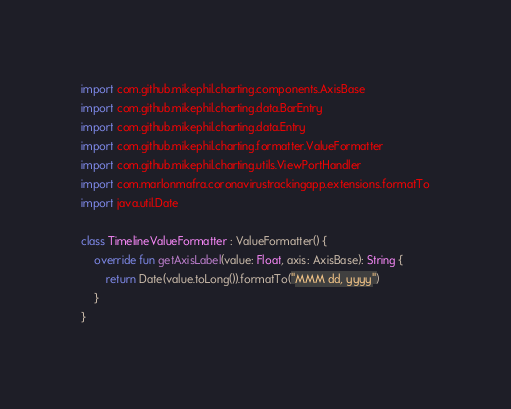<code> <loc_0><loc_0><loc_500><loc_500><_Kotlin_>import com.github.mikephil.charting.components.AxisBase
import com.github.mikephil.charting.data.BarEntry
import com.github.mikephil.charting.data.Entry
import com.github.mikephil.charting.formatter.ValueFormatter
import com.github.mikephil.charting.utils.ViewPortHandler
import com.marlonmafra.coronavirustrackingapp.extensions.formatTo
import java.util.Date

class TimelineValueFormatter : ValueFormatter() {
    override fun getAxisLabel(value: Float, axis: AxisBase): String {
        return Date(value.toLong()).formatTo("MMM dd, yyyy")
    }
}</code> 